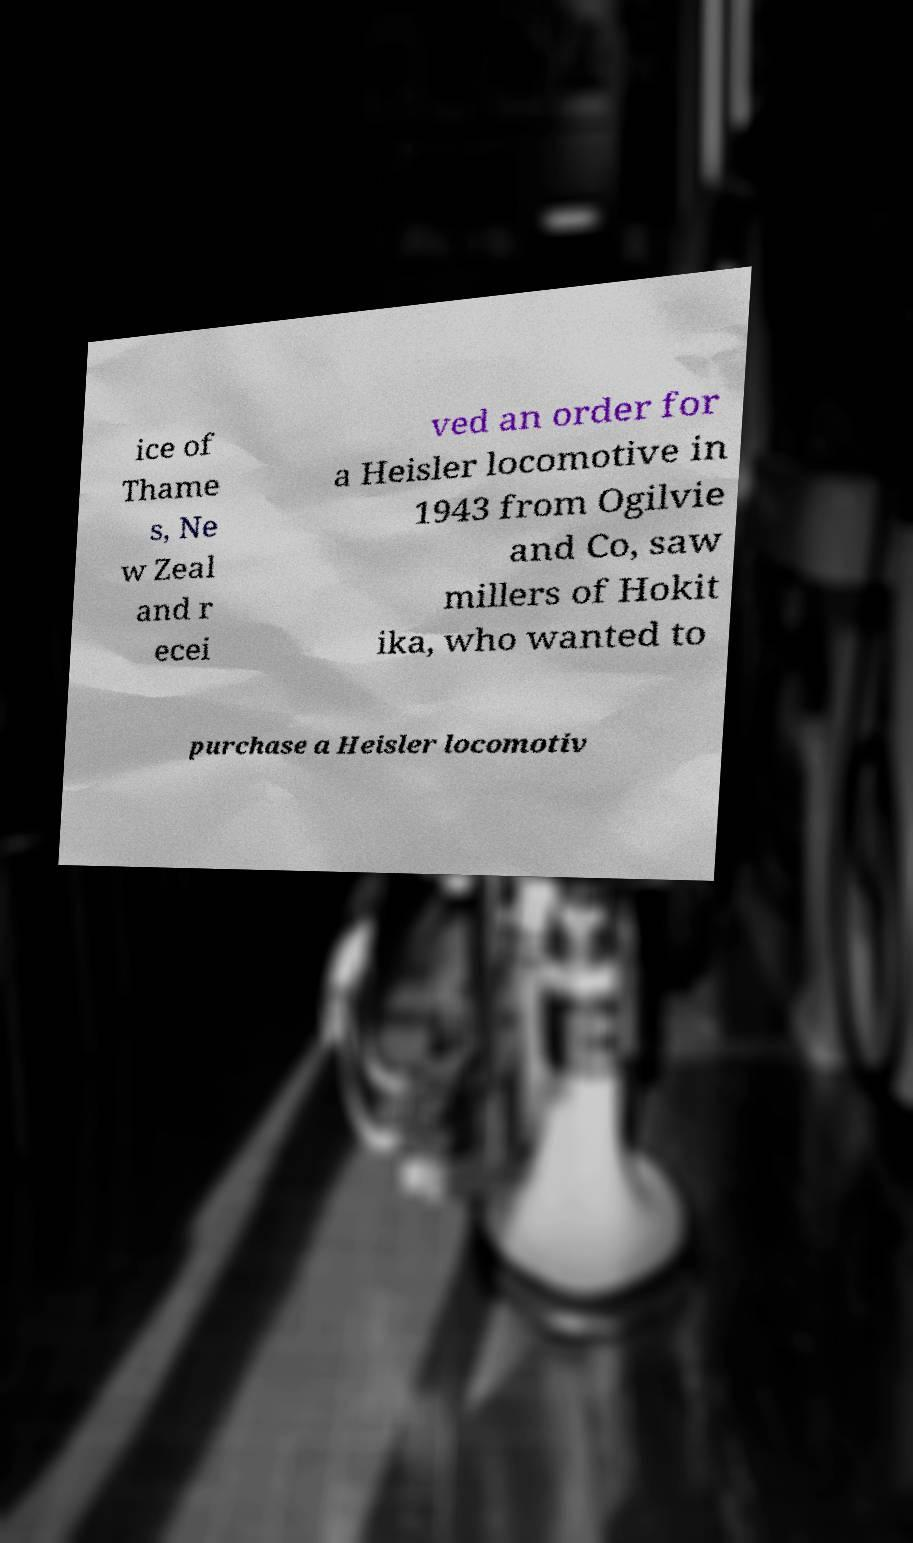Could you extract and type out the text from this image? ice of Thame s, Ne w Zeal and r ecei ved an order for a Heisler locomotive in 1943 from Ogilvie and Co, saw millers of Hokit ika, who wanted to purchase a Heisler locomotiv 